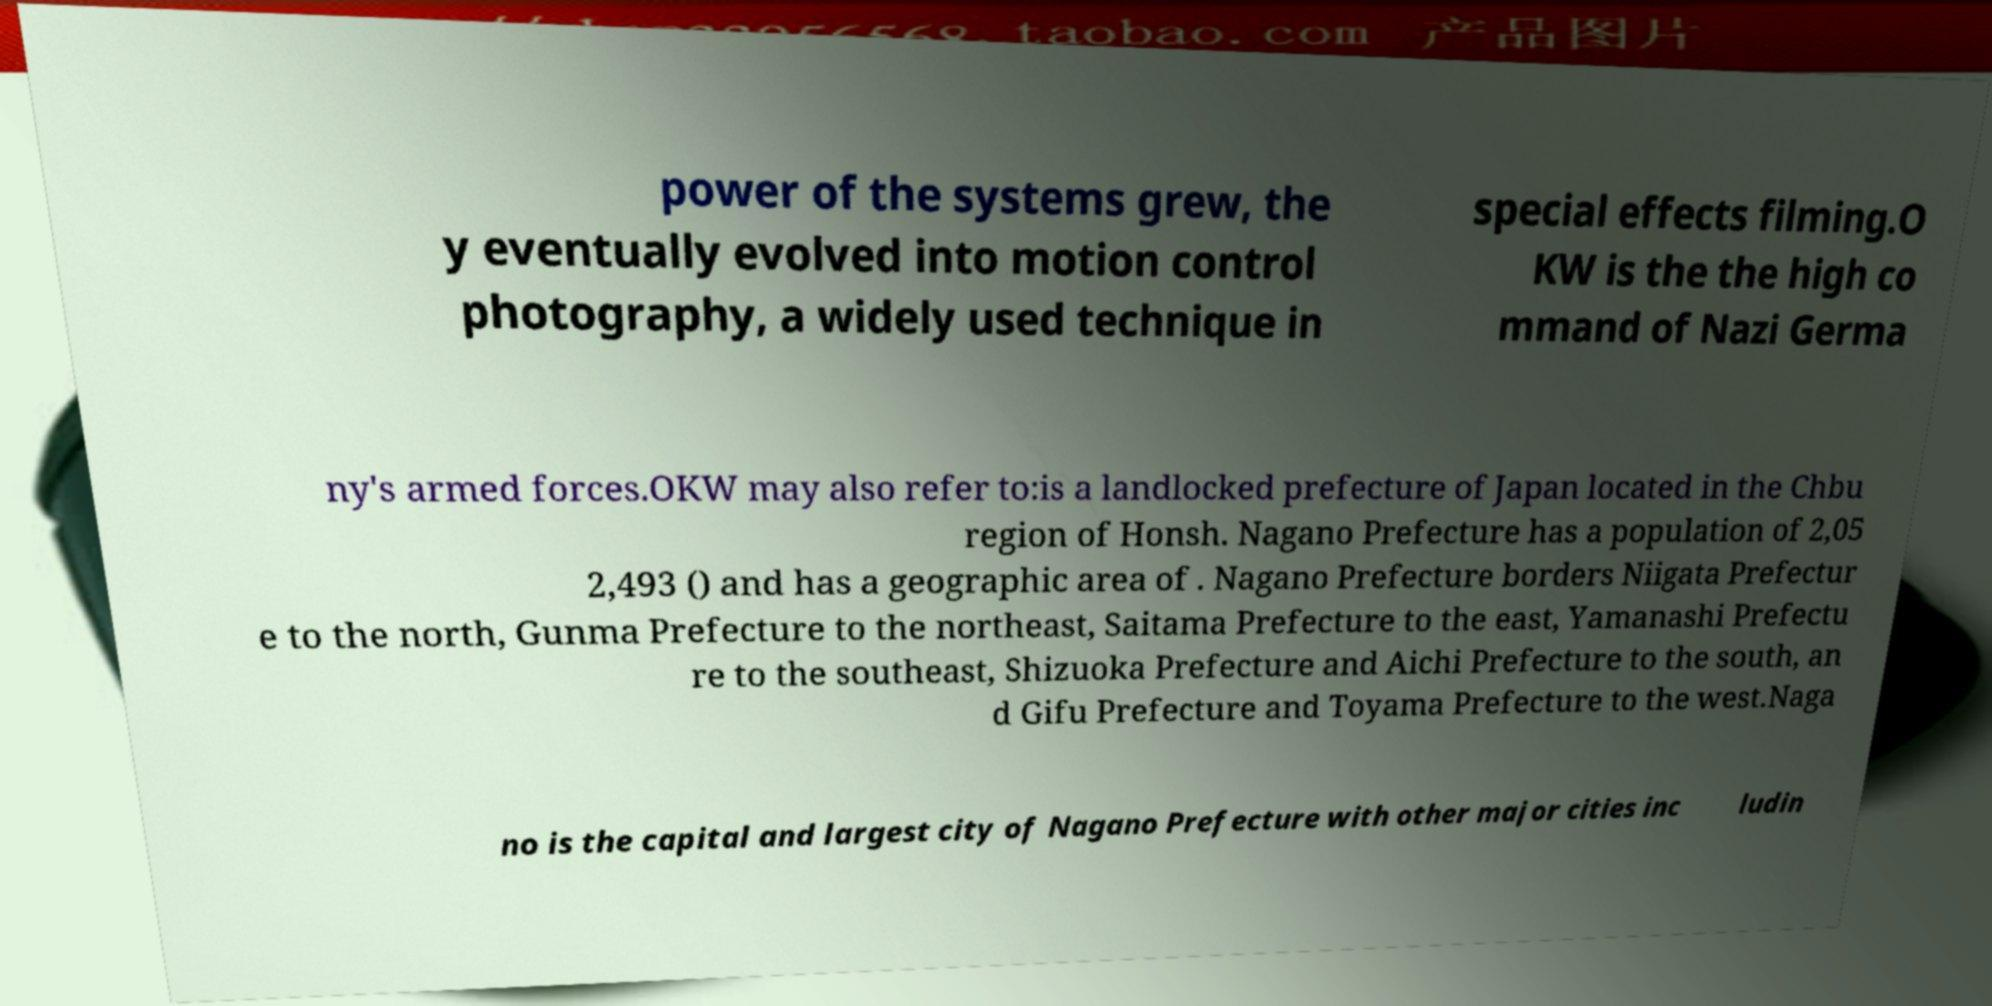Can you accurately transcribe the text from the provided image for me? power of the systems grew, the y eventually evolved into motion control photography, a widely used technique in special effects filming.O KW is the the high co mmand of Nazi Germa ny's armed forces.OKW may also refer to:is a landlocked prefecture of Japan located in the Chbu region of Honsh. Nagano Prefecture has a population of 2,05 2,493 () and has a geographic area of . Nagano Prefecture borders Niigata Prefectur e to the north, Gunma Prefecture to the northeast, Saitama Prefecture to the east, Yamanashi Prefectu re to the southeast, Shizuoka Prefecture and Aichi Prefecture to the south, an d Gifu Prefecture and Toyama Prefecture to the west.Naga no is the capital and largest city of Nagano Prefecture with other major cities inc ludin 